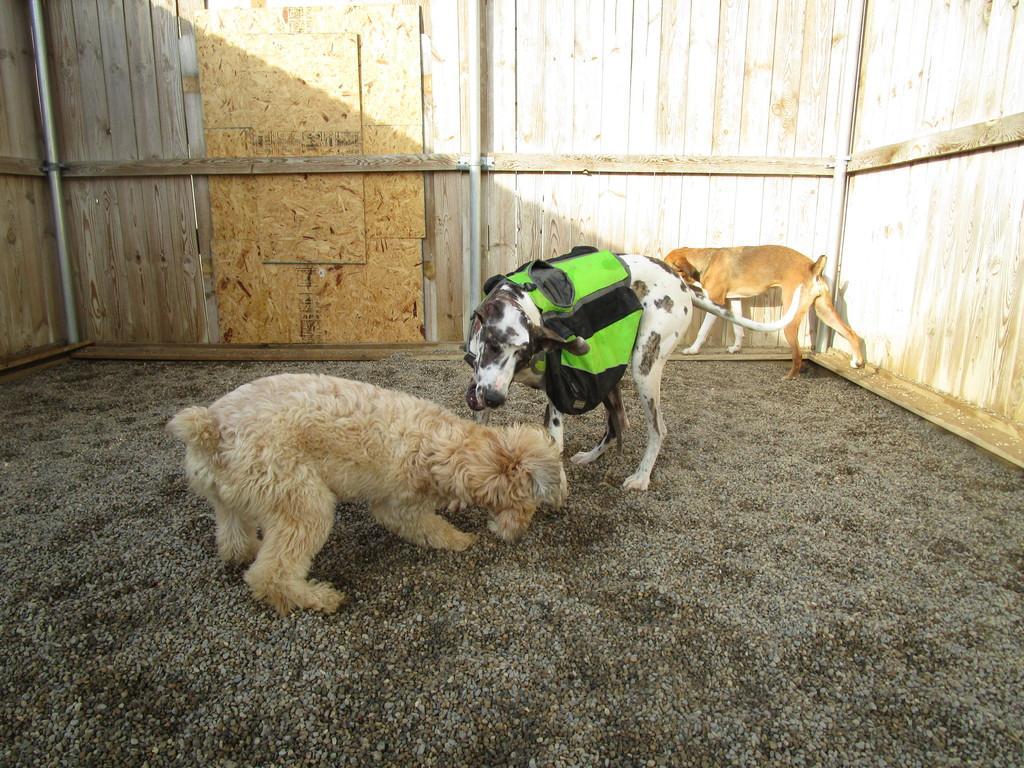Please provide a concise description of this image. In this image we can see group of dogs on the ground, here it is in brown color, at the background there is wooden wall. 